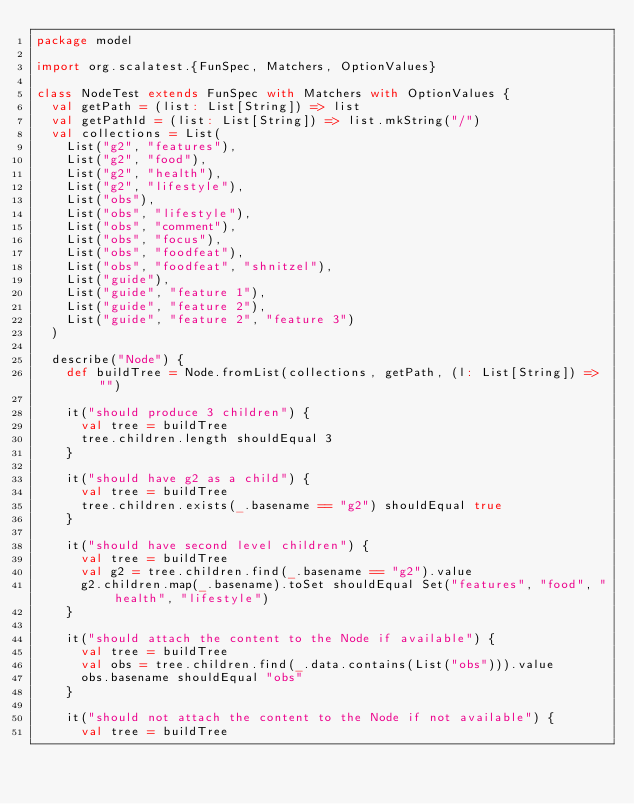Convert code to text. <code><loc_0><loc_0><loc_500><loc_500><_Scala_>package model

import org.scalatest.{FunSpec, Matchers, OptionValues}

class NodeTest extends FunSpec with Matchers with OptionValues {
  val getPath = (list: List[String]) => list
  val getPathId = (list: List[String]) => list.mkString("/")
  val collections = List(
    List("g2", "features"),
    List("g2", "food"),
    List("g2", "health"),
    List("g2", "lifestyle"),
    List("obs"),
    List("obs", "lifestyle"),
    List("obs", "comment"),
    List("obs", "focus"),
    List("obs", "foodfeat"),
    List("obs", "foodfeat", "shnitzel"),
    List("guide"),
    List("guide", "feature 1"),
    List("guide", "feature 2"),
    List("guide", "feature 2", "feature 3")
  )

  describe("Node") {
    def buildTree = Node.fromList(collections, getPath, (l: List[String]) => "")

    it("should produce 3 children") {
      val tree = buildTree
      tree.children.length shouldEqual 3
    }

    it("should have g2 as a child") {
      val tree = buildTree
      tree.children.exists(_.basename == "g2") shouldEqual true
    }

    it("should have second level children") {
      val tree = buildTree
      val g2 = tree.children.find(_.basename == "g2").value
      g2.children.map(_.basename).toSet shouldEqual Set("features", "food", "health", "lifestyle")
    }

    it("should attach the content to the Node if available") {
      val tree = buildTree
      val obs = tree.children.find(_.data.contains(List("obs"))).value
      obs.basename shouldEqual "obs"
    }

    it("should not attach the content to the Node if not available") {
      val tree = buildTree</code> 